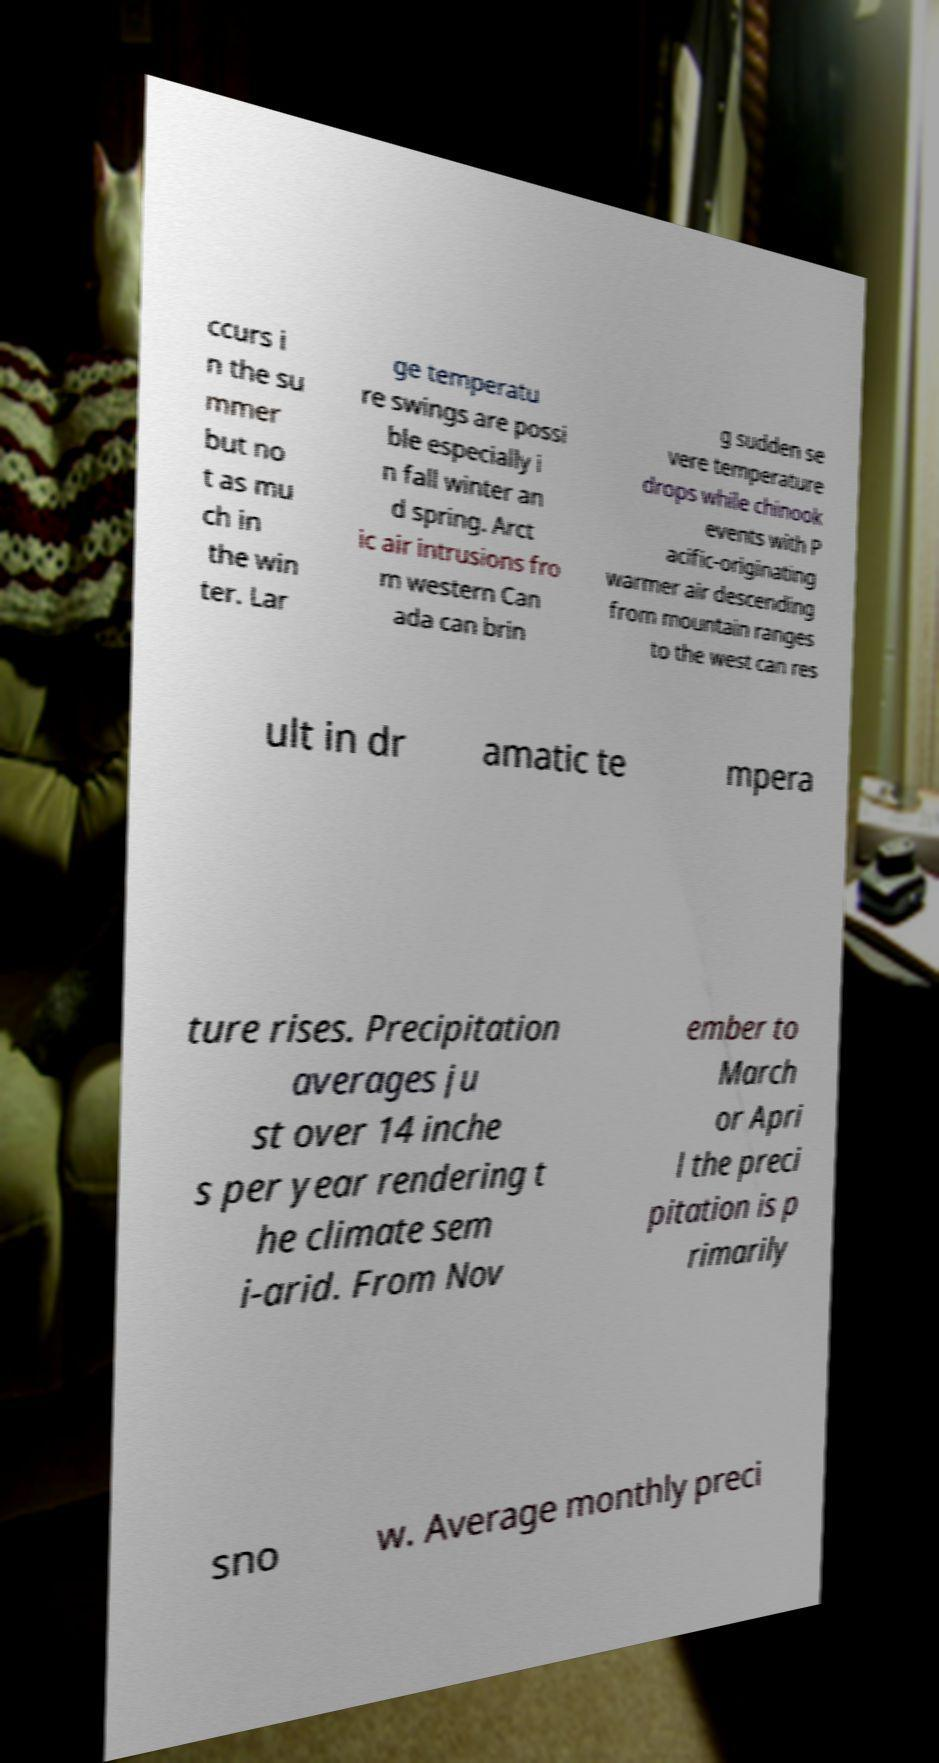There's text embedded in this image that I need extracted. Can you transcribe it verbatim? ccurs i n the su mmer but no t as mu ch in the win ter. Lar ge temperatu re swings are possi ble especially i n fall winter an d spring. Arct ic air intrusions fro m western Can ada can brin g sudden se vere temperature drops while chinook events with P acific-originating warmer air descending from mountain ranges to the west can res ult in dr amatic te mpera ture rises. Precipitation averages ju st over 14 inche s per year rendering t he climate sem i-arid. From Nov ember to March or Apri l the preci pitation is p rimarily sno w. Average monthly preci 